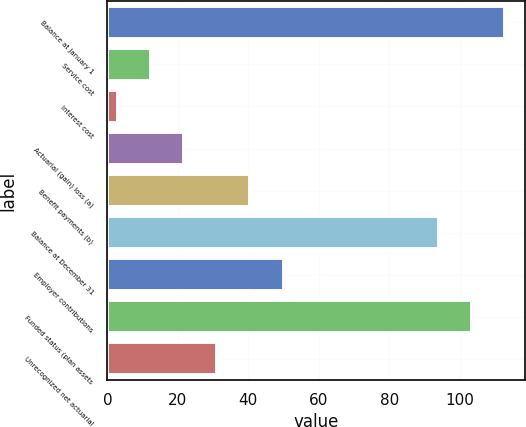Convert chart. <chart><loc_0><loc_0><loc_500><loc_500><bar_chart><fcel>Balance at January 1<fcel>Service cost<fcel>Interest cost<fcel>Actuarial (gain) loss (a)<fcel>Benefit payments (b)<fcel>Balance at December 31<fcel>Employer contributions<fcel>Funded status (plan assets<fcel>Unrecognized net actuarial<nl><fcel>112.8<fcel>12.4<fcel>3<fcel>21.8<fcel>40.6<fcel>94<fcel>50<fcel>103.4<fcel>31.2<nl></chart> 